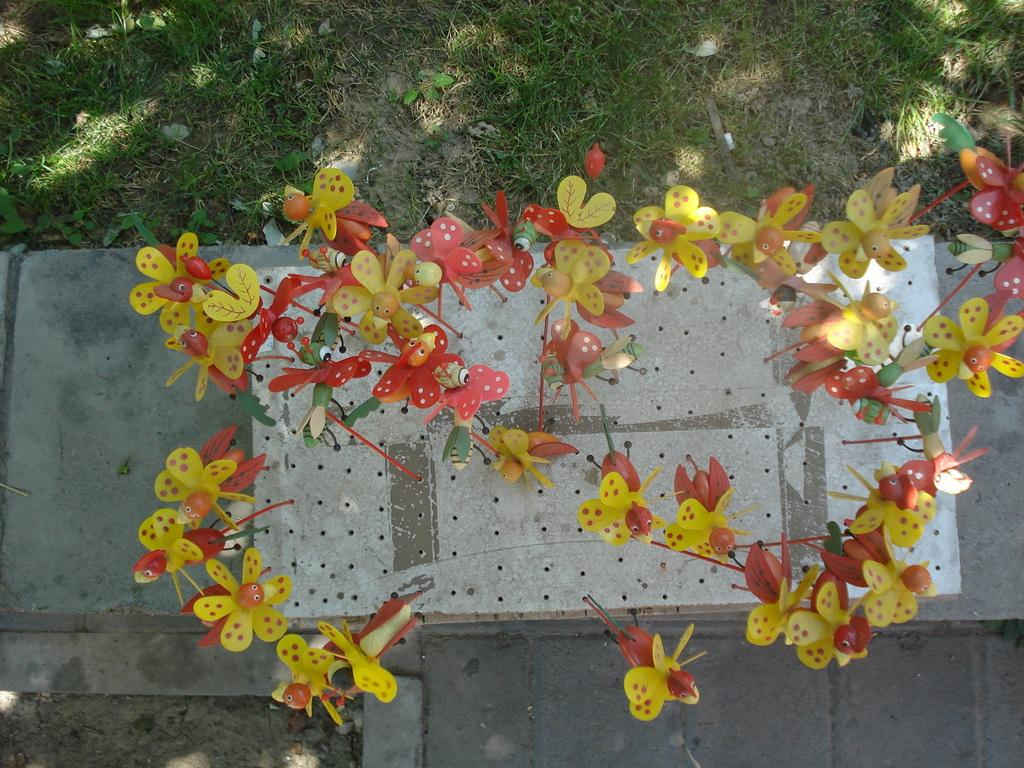What type of decorations can be seen on the path in the image? There are decorative flowers on the path in the image. What type of vegetation is visible behind the flowers in the image? There is grass visible behind the flowers in the image. What type of owl can be seen sitting on the crate in the image? There is no owl or crate present in the image; it only features decorative flowers on the path and grass behind them. 